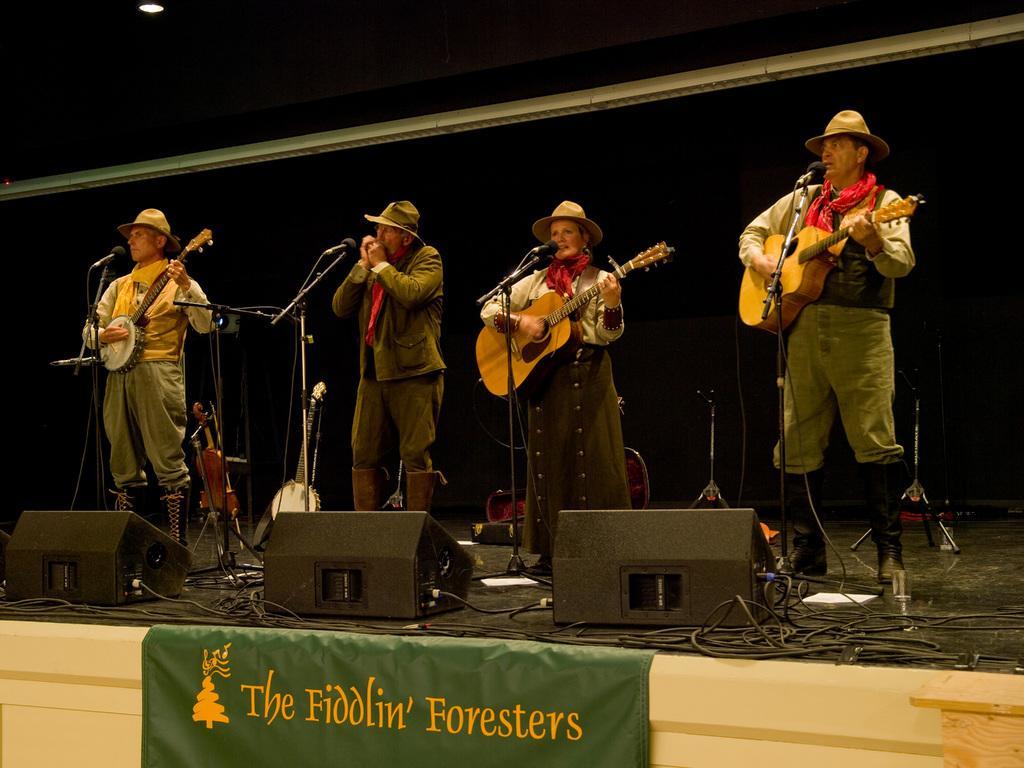In one or two sentences, can you explain what this image depicts? In this image I can see four people standing in-front of the mic and playing the musical instruments. 